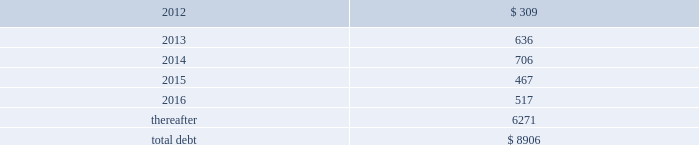Debt maturities 2013 the table presents aggregate debt maturities as of december 31 , 2011 , excluding market value adjustments : millions .
As of both december 31 , 2011 and december 31 , 2010 , we have reclassified as long-term debt approximately $ 100 million of debt due within one year that we intend to refinance .
This reclassification reflects our ability and intent to refinance any short-term borrowings and certain current maturities of long- term debt on a long-term basis .
Mortgaged properties 2013 equipment with a carrying value of approximately $ 2.9 billion and $ 3.2 billion at december 31 , 2011 and 2010 , respectively , served as collateral for capital leases and other types of equipment obligations in accordance with the secured financing arrangements utilized to acquire such railroad equipment .
As a result of the merger of missouri pacific railroad company ( mprr ) with and into uprr on january 1 , 1997 , and pursuant to the underlying indentures for the mprr mortgage bonds , uprr must maintain the same value of assets after the merger in order to comply with the security requirements of the mortgage bonds .
As of the merger date , the value of the mprr assets that secured the mortgage bonds was approximately $ 6.0 billion .
In accordance with the terms of the indentures , this collateral value must be maintained during the entire term of the mortgage bonds irrespective of the outstanding balance of such bonds .
Credit facilities 2013 during the second quarter of 2011 , we replaced our $ 1.9 billion revolving credit facility , which was scheduled to expire in april 2012 , with a new $ 1.8 billion facility that expires in may 2015 ( the facility ) .
The facility is based on substantially similar terms as those in the previous credit facility .
On december 31 , 2011 , we had $ 1.8 billion of credit available under the facility , which is designated for general corporate purposes and supports the issuance of commercial paper .
We did not draw on either facility during 2011 .
Commitment fees and interest rates payable under the facility are similar to fees and rates available to comparably rated , investment-grade borrowers .
The facility allows for borrowings at floating rates based on london interbank offered rates , plus a spread , depending upon our senior unsecured debt ratings .
The facility requires the corporation to maintain a debt-to-net-worth coverage ratio as a condition to making a borrowing .
At december 31 , 2011 , and december 31 , 2010 ( and at all times during the year ) , we were in compliance with this covenant .
The definition of debt used for purposes of calculating the debt-to-net-worth coverage ratio includes , among other things , certain credit arrangements , capital leases , guarantees and unfunded and vested pension benefits under title iv of erisa .
At december 31 , 2011 , the debt-to-net-worth coverage ratio allowed us to carry up to $ 37.2 billion of debt ( as defined in the facility ) , and we had $ 9.5 billion of debt ( as defined in the facility ) outstanding at that date .
Under our current capital plans , we expect to continue to satisfy the debt-to-net-worth coverage ratio ; however , many factors beyond our reasonable control ( including the risk factors in item 1a of this report ) could affect our ability to comply with this provision in the future .
The facility does not include any other financial restrictions , credit rating triggers ( other than rating-dependent pricing ) , or any other provision that could require us to post collateral .
The facility also includes a $ 75 million cross-default provision and a change-of-control provision .
During 2011 , we did not issue or repay any commercial paper and , at december 31 , 2011 , we had no commercial paper outstanding .
Outstanding commercial paper balances are supported by our revolving credit facility but do not reduce the amount of borrowings available under the facility .
Dividend restrictions 2013 our revolving credit facility includes a debt-to-net worth covenant ( discussed in the credit facilities section above ) that , under certain circumstances , restricts the payment of cash .
At december 31 , 2011 , what is the additional borrowing capacity in billions pursuant to the current debt coverage restrictions? 
Computations: (37.2 - 9.5)
Answer: 27.7. Debt maturities 2013 the table presents aggregate debt maturities as of december 31 , 2011 , excluding market value adjustments : millions .
As of both december 31 , 2011 and december 31 , 2010 , we have reclassified as long-term debt approximately $ 100 million of debt due within one year that we intend to refinance .
This reclassification reflects our ability and intent to refinance any short-term borrowings and certain current maturities of long- term debt on a long-term basis .
Mortgaged properties 2013 equipment with a carrying value of approximately $ 2.9 billion and $ 3.2 billion at december 31 , 2011 and 2010 , respectively , served as collateral for capital leases and other types of equipment obligations in accordance with the secured financing arrangements utilized to acquire such railroad equipment .
As a result of the merger of missouri pacific railroad company ( mprr ) with and into uprr on january 1 , 1997 , and pursuant to the underlying indentures for the mprr mortgage bonds , uprr must maintain the same value of assets after the merger in order to comply with the security requirements of the mortgage bonds .
As of the merger date , the value of the mprr assets that secured the mortgage bonds was approximately $ 6.0 billion .
In accordance with the terms of the indentures , this collateral value must be maintained during the entire term of the mortgage bonds irrespective of the outstanding balance of such bonds .
Credit facilities 2013 during the second quarter of 2011 , we replaced our $ 1.9 billion revolving credit facility , which was scheduled to expire in april 2012 , with a new $ 1.8 billion facility that expires in may 2015 ( the facility ) .
The facility is based on substantially similar terms as those in the previous credit facility .
On december 31 , 2011 , we had $ 1.8 billion of credit available under the facility , which is designated for general corporate purposes and supports the issuance of commercial paper .
We did not draw on either facility during 2011 .
Commitment fees and interest rates payable under the facility are similar to fees and rates available to comparably rated , investment-grade borrowers .
The facility allows for borrowings at floating rates based on london interbank offered rates , plus a spread , depending upon our senior unsecured debt ratings .
The facility requires the corporation to maintain a debt-to-net-worth coverage ratio as a condition to making a borrowing .
At december 31 , 2011 , and december 31 , 2010 ( and at all times during the year ) , we were in compliance with this covenant .
The definition of debt used for purposes of calculating the debt-to-net-worth coverage ratio includes , among other things , certain credit arrangements , capital leases , guarantees and unfunded and vested pension benefits under title iv of erisa .
At december 31 , 2011 , the debt-to-net-worth coverage ratio allowed us to carry up to $ 37.2 billion of debt ( as defined in the facility ) , and we had $ 9.5 billion of debt ( as defined in the facility ) outstanding at that date .
Under our current capital plans , we expect to continue to satisfy the debt-to-net-worth coverage ratio ; however , many factors beyond our reasonable control ( including the risk factors in item 1a of this report ) could affect our ability to comply with this provision in the future .
The facility does not include any other financial restrictions , credit rating triggers ( other than rating-dependent pricing ) , or any other provision that could require us to post collateral .
The facility also includes a $ 75 million cross-default provision and a change-of-control provision .
During 2011 , we did not issue or repay any commercial paper and , at december 31 , 2011 , we had no commercial paper outstanding .
Outstanding commercial paper balances are supported by our revolving credit facility but do not reduce the amount of borrowings available under the facility .
Dividend restrictions 2013 our revolving credit facility includes a debt-to-net worth covenant ( discussed in the credit facilities section above ) that , under certain circumstances , restricts the payment of cash .
What percent of debt is current as of 12/31/2011? 
Computations: (309 / 8906)
Answer: 0.0347. 